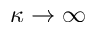Convert formula to latex. <formula><loc_0><loc_0><loc_500><loc_500>\kappa \rightarrow \infty</formula> 